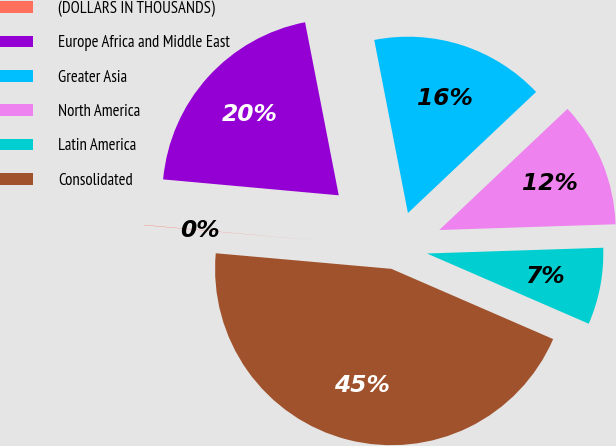<chart> <loc_0><loc_0><loc_500><loc_500><pie_chart><fcel>(DOLLARS IN THOUSANDS)<fcel>Europe Africa and Middle East<fcel>Greater Asia<fcel>North America<fcel>Latin America<fcel>Consolidated<nl><fcel>0.03%<fcel>20.5%<fcel>16.01%<fcel>11.53%<fcel>7.04%<fcel>44.89%<nl></chart> 